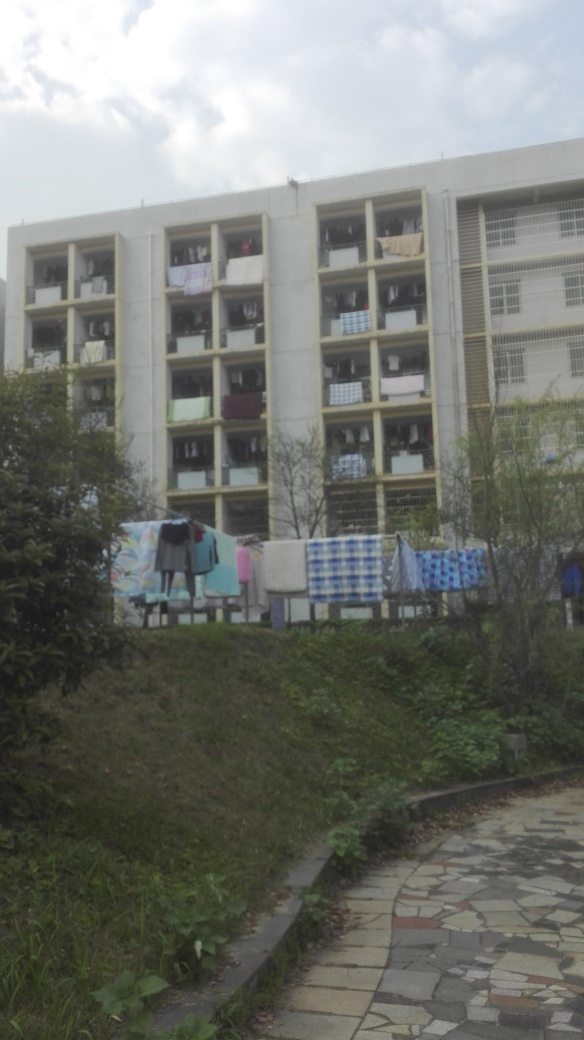Is the frame of this image well-composed? The framing of the image could be more balanced. The picture captures the building and hanging laundry prominently, but the composition lacks dynamic balance. The bottom of the frame is heavy with dense vegetation, which could be cropped for better visual harmony, allowing the eye to focus on the subject with ease. 